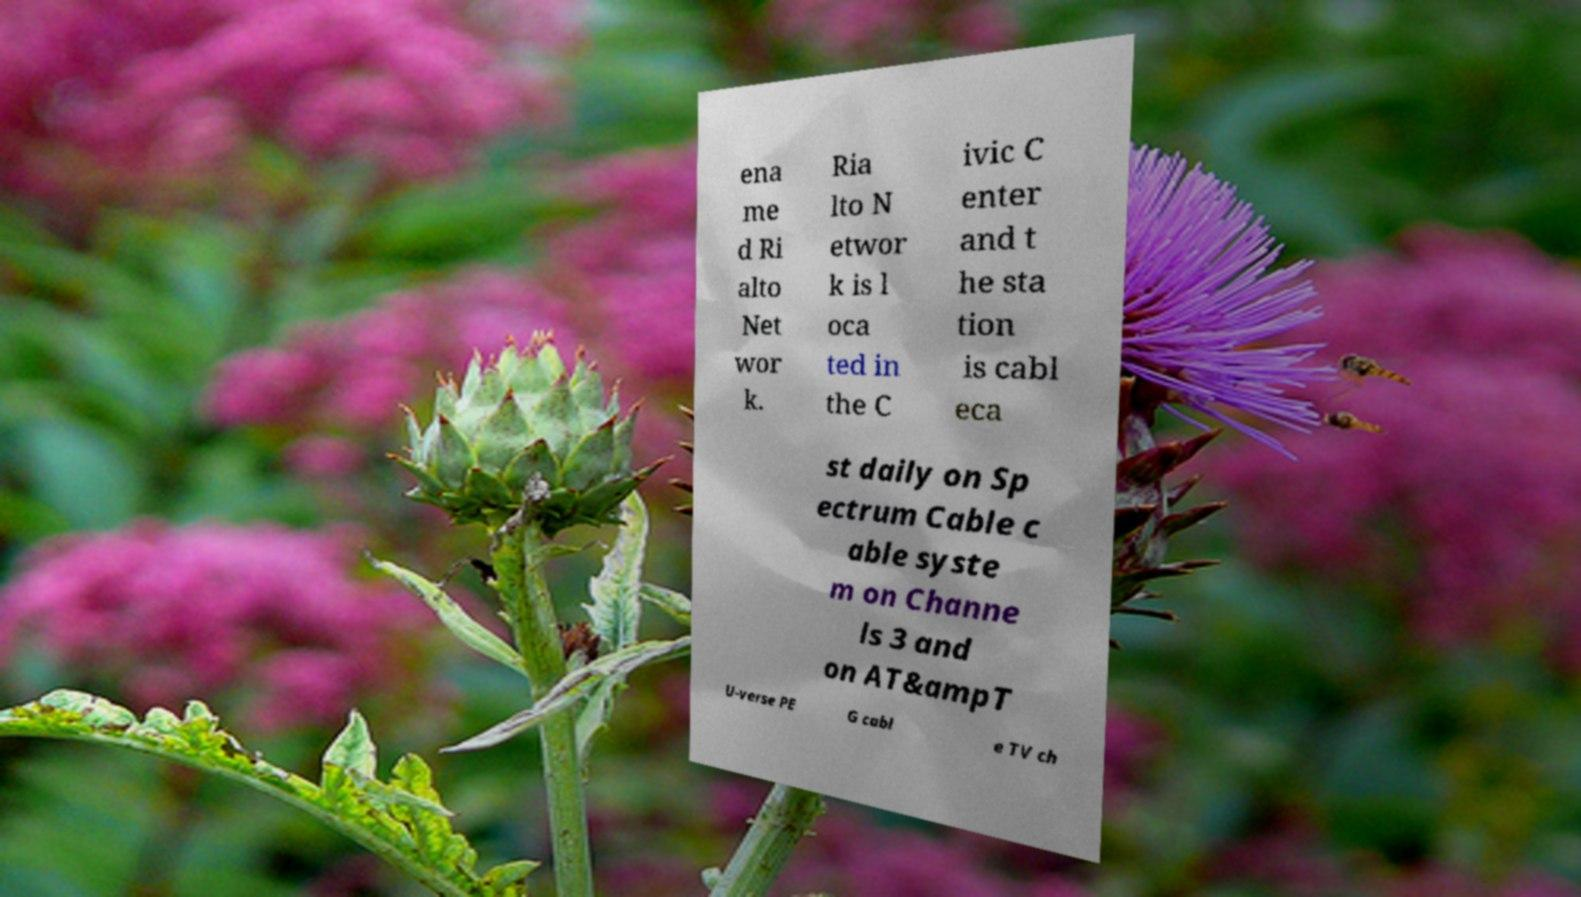Can you accurately transcribe the text from the provided image for me? ena me d Ri alto Net wor k. Ria lto N etwor k is l oca ted in the C ivic C enter and t he sta tion is cabl eca st daily on Sp ectrum Cable c able syste m on Channe ls 3 and on AT&ampT U-verse PE G cabl e TV ch 